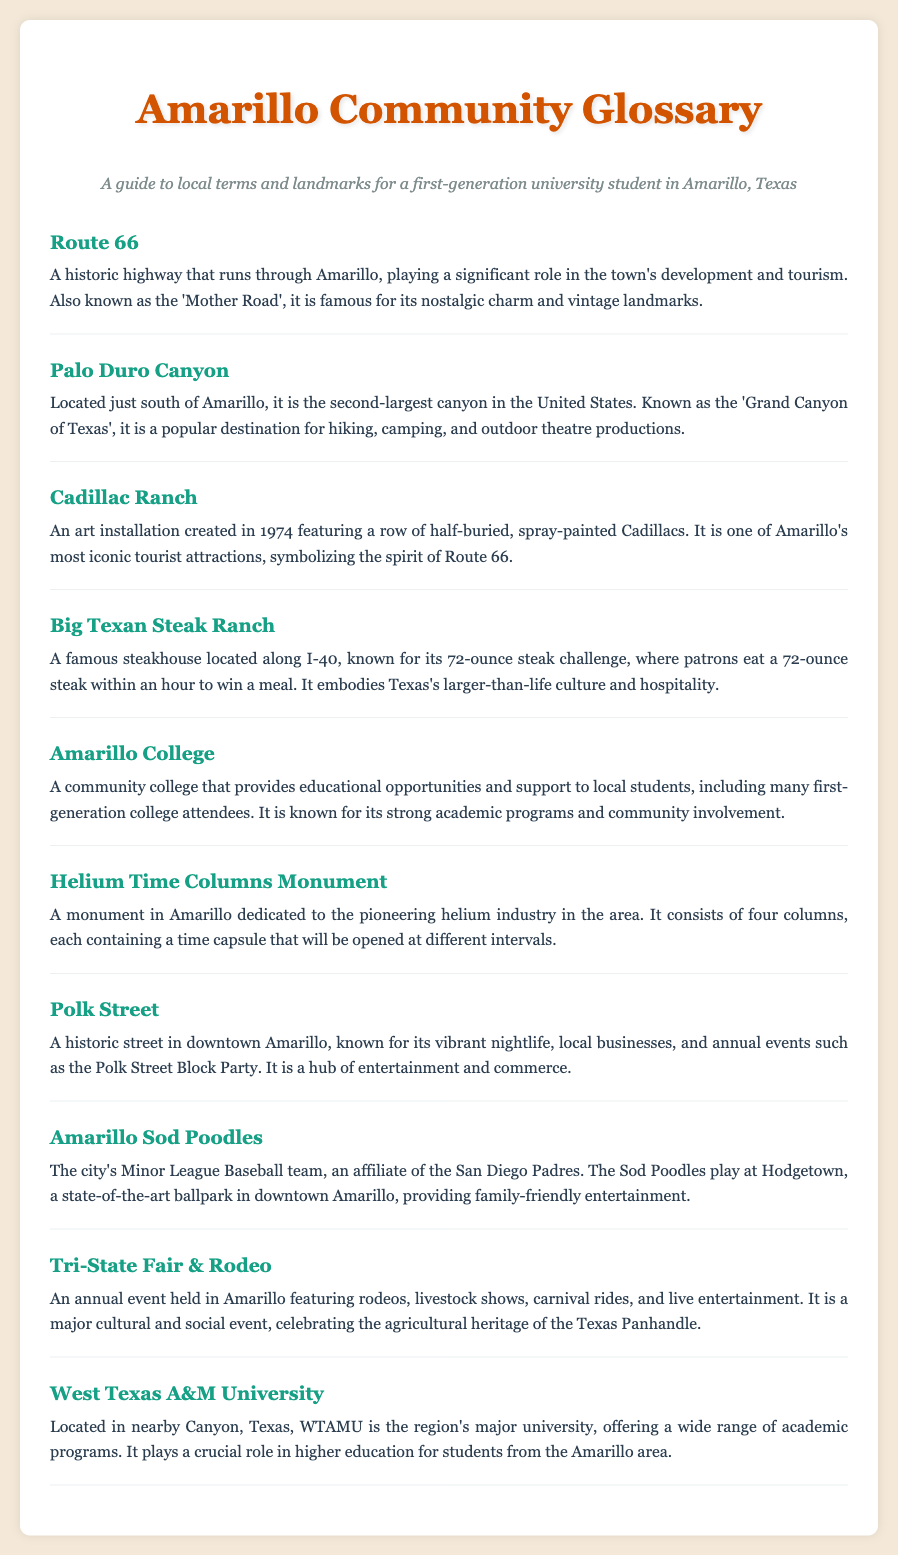What is the second-largest canyon in the United States? The document states that Palo Duro Canyon is known as the second-largest canyon in the United States.
Answer: Palo Duro Canyon What is the famous challenge at the Big Texan Steak Ranch? The document mentions the 72-ounce steak challenge at the Big Texan Steak Ranch.
Answer: 72-ounce steak challenge What annual event celebrates the agricultural heritage of the Texas Panhandle? The Tri-State Fair & Rodeo is described as celebrating the agricultural heritage of the Texas Panhandle.
Answer: Tri-State Fair & Rodeo Where do the Amarillo Sod Poodles play? The document specifies that the Amarillo Sod Poodles play at Hodgetown.
Answer: Hodgetown What historic highway runs through Amarillo? Route 66 is identified in the document as the historic highway that runs through Amarillo.
Answer: Route 66 Which institution provides educational opportunities to first-generation college attendees in Amarillo? Amarillo College is mentioned as providing educational opportunities to local students, including first-generation college attendees.
Answer: Amarillo College What is the Helium Time Columns Monument dedicated to? The document states that the Helium Time Columns Monument is dedicated to the pioneering helium industry in the area.
Answer: Helium industry What is Polk Street known for? The document says Polk Street is known for its vibrant nightlife, local businesses, and annual events.
Answer: Vibrant nightlife Which university plays a crucial role in higher education for Amarillo area students? West Texas A&M University is mentioned as playing a crucial role in higher education for students from the Amarillo area.
Answer: West Texas A&M University 